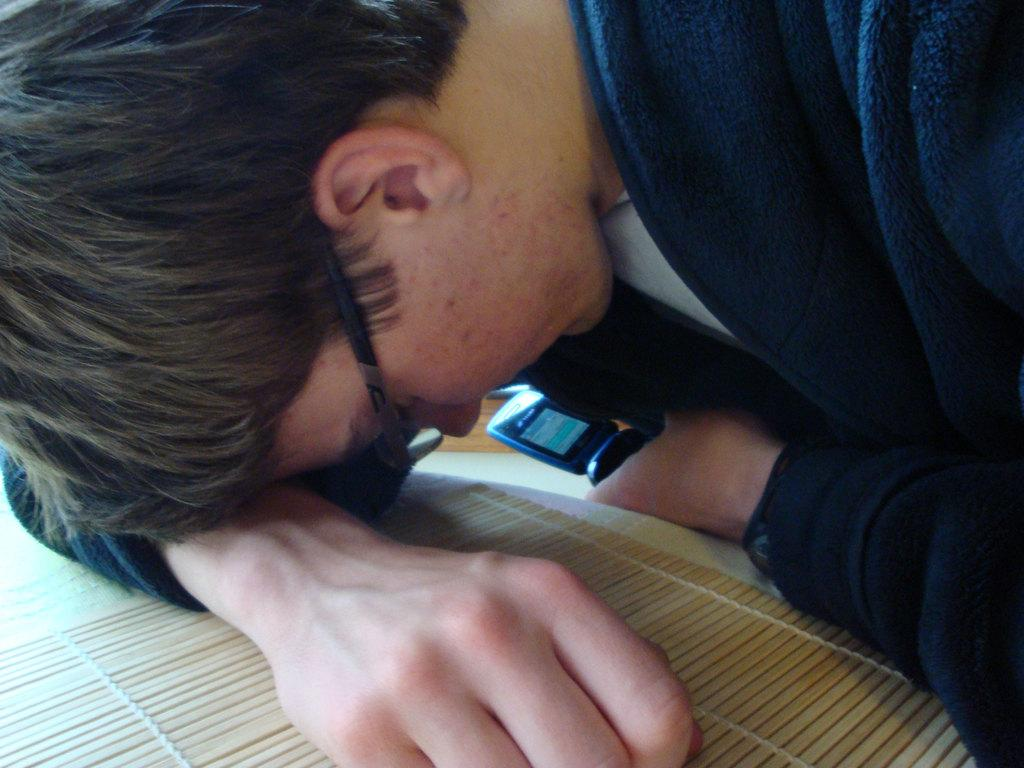Who is present in the image? There is a man in the image. What is the man doing in the image? The man is leaning on a table in the image. What object is the man holding in his hand? The man is holding a mobile phone in his hand. What piece of furniture is in the image? There is a table in the image. What is on top of the table? There is a table runner on the table. What type of juice is the man drinking from the wing in the image? There is no juice or wing present in the image; the man is holding a mobile phone and leaning on a table. 